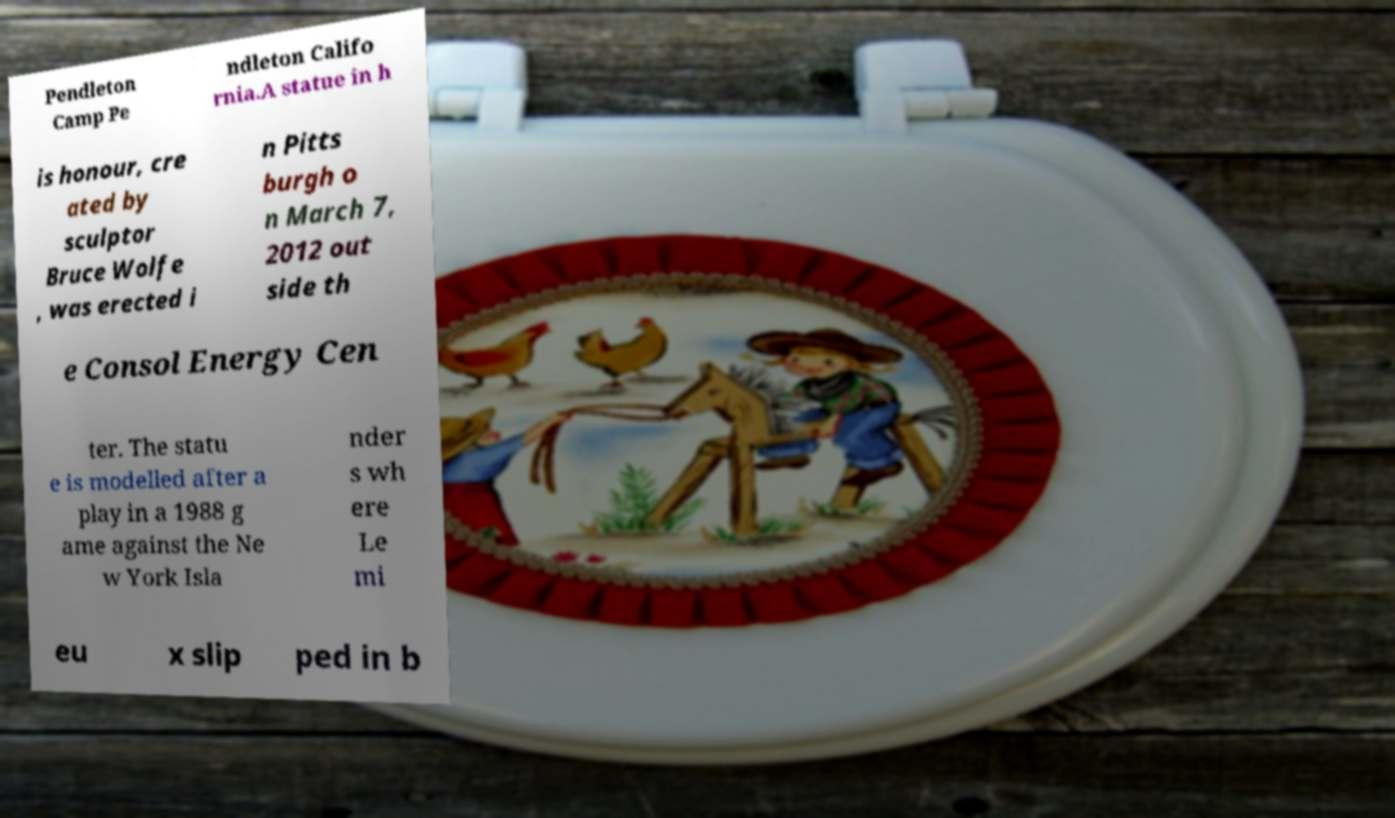Please read and relay the text visible in this image. What does it say? Pendleton Camp Pe ndleton Califo rnia.A statue in h is honour, cre ated by sculptor Bruce Wolfe , was erected i n Pitts burgh o n March 7, 2012 out side th e Consol Energy Cen ter. The statu e is modelled after a play in a 1988 g ame against the Ne w York Isla nder s wh ere Le mi eu x slip ped in b 